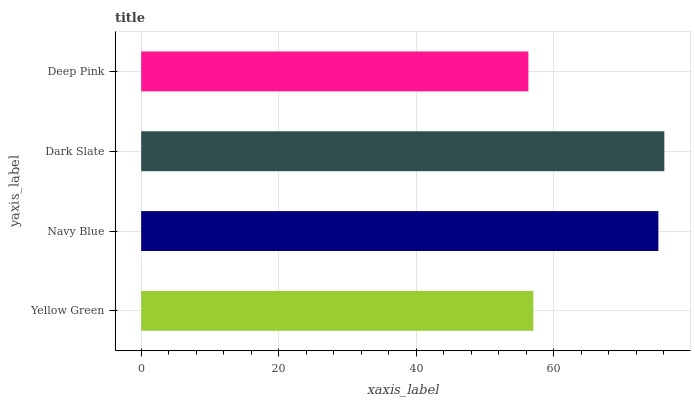Is Deep Pink the minimum?
Answer yes or no. Yes. Is Dark Slate the maximum?
Answer yes or no. Yes. Is Navy Blue the minimum?
Answer yes or no. No. Is Navy Blue the maximum?
Answer yes or no. No. Is Navy Blue greater than Yellow Green?
Answer yes or no. Yes. Is Yellow Green less than Navy Blue?
Answer yes or no. Yes. Is Yellow Green greater than Navy Blue?
Answer yes or no. No. Is Navy Blue less than Yellow Green?
Answer yes or no. No. Is Navy Blue the high median?
Answer yes or no. Yes. Is Yellow Green the low median?
Answer yes or no. Yes. Is Deep Pink the high median?
Answer yes or no. No. Is Deep Pink the low median?
Answer yes or no. No. 